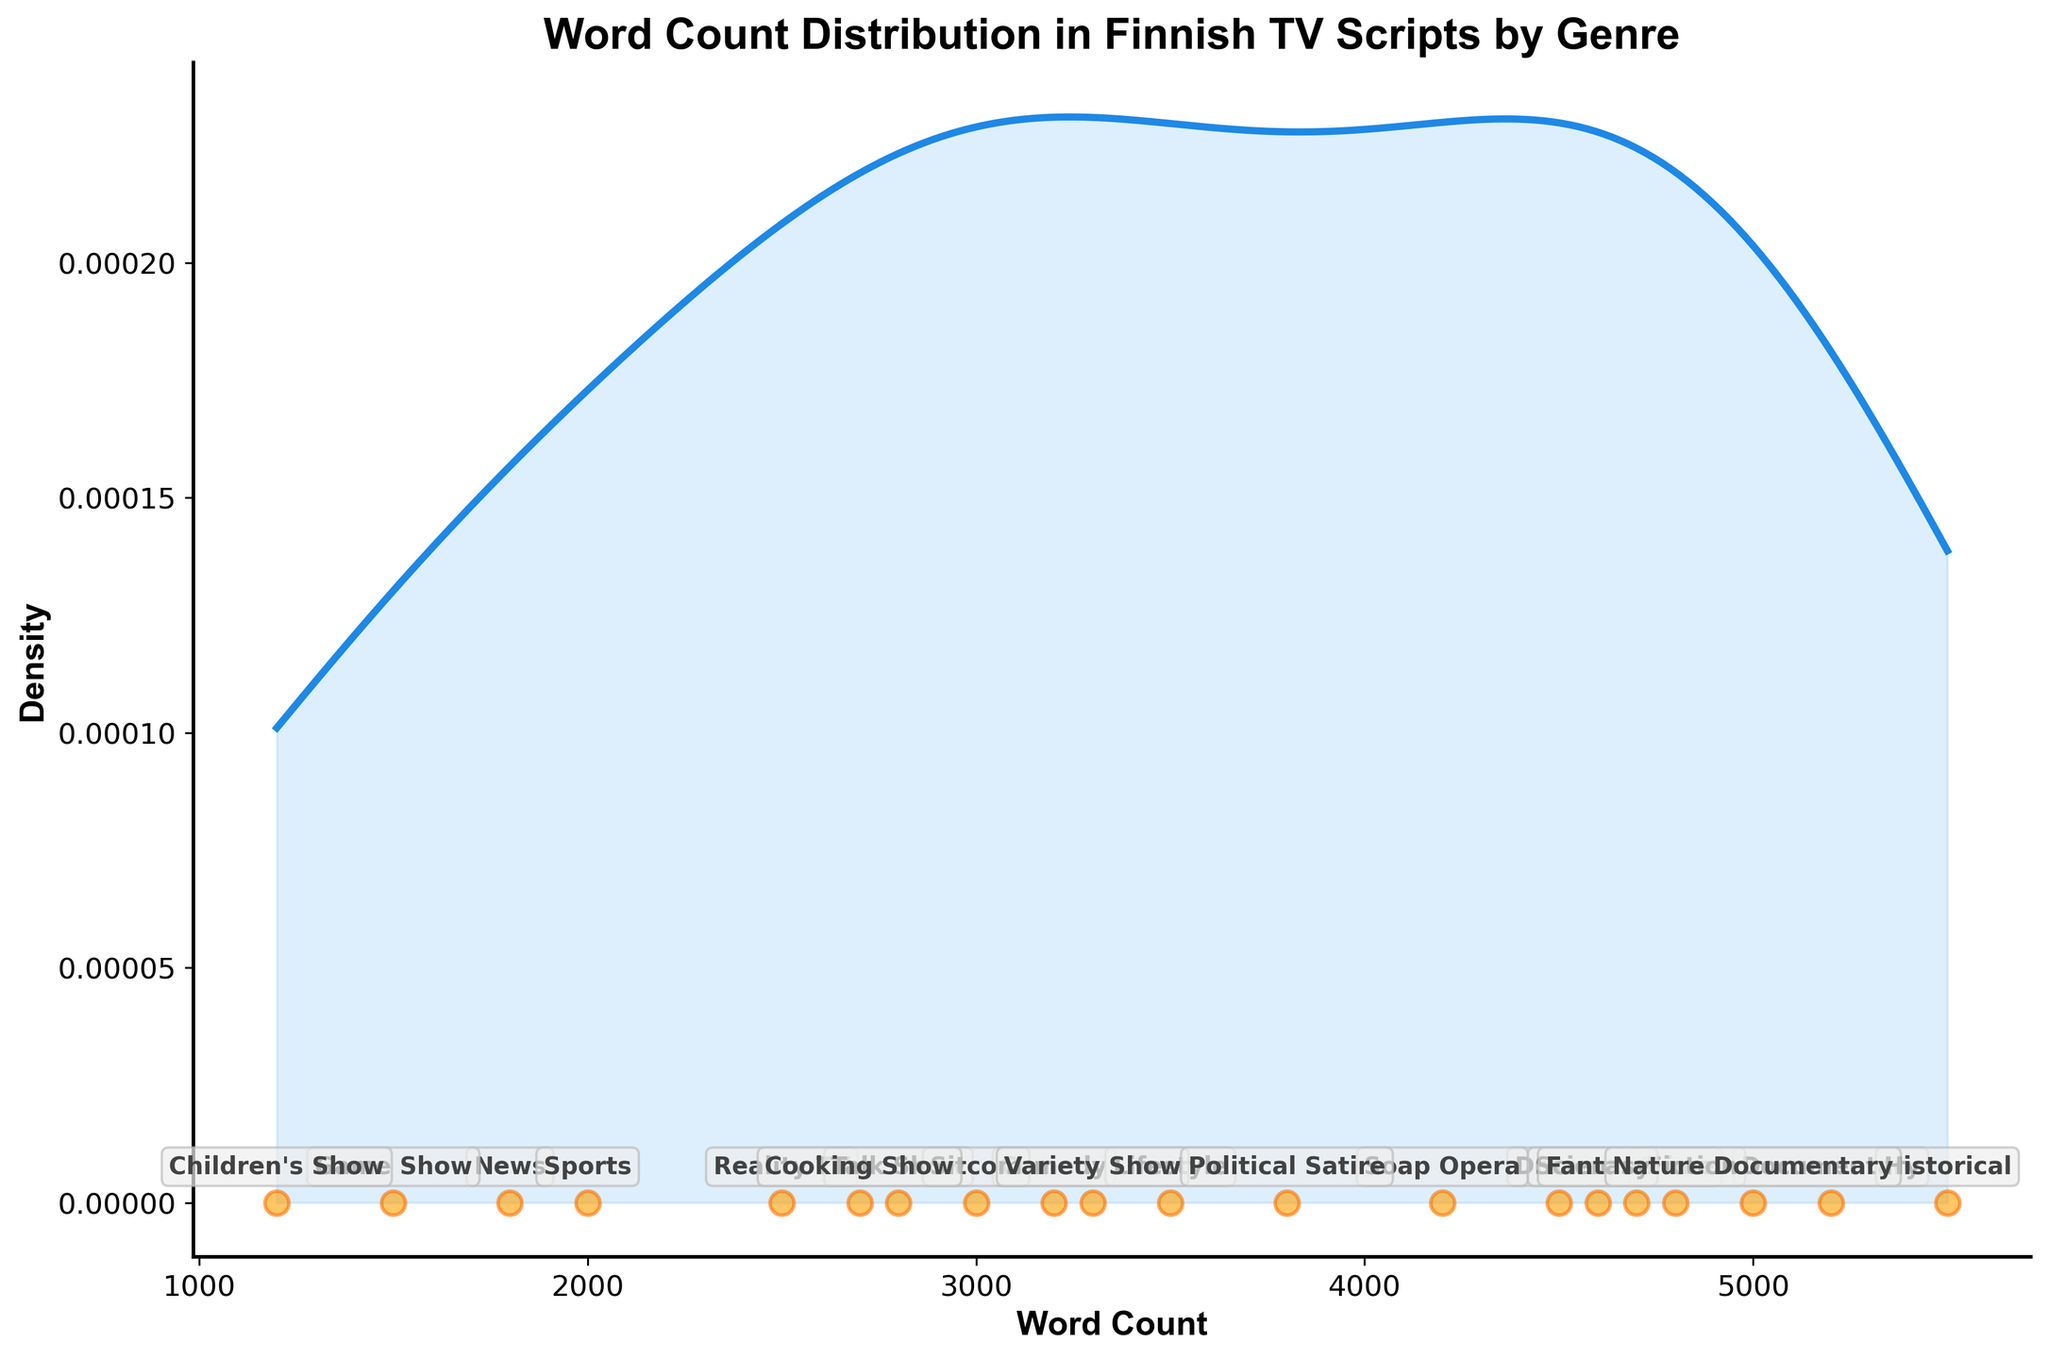What's the title of the figure? The title of the figure is written at the top and is clearly visible.
Answer: Word Count Distribution in Finnish TV Scripts by Genre How many genres are represented in the plot? By counting the number of annotations for genre names on the plot, we can determine the number of genres represented.
Answer: 20 What range of word counts is covered in the plot? By observing the x-axis, we can see the minimum and maximum values of word counts.
Answer: 1200 to 5500 Which genre has the highest word count? Locate the annotation with the highest word count on the plot.
Answer: Historical Which genre has the lowest word count? Locate the annotation with the lowest word count on the plot.
Answer: Children's Show Is the word count for 'Comedy' greater than 'Sitcom'? Compare the word count annotations of 'Comedy' and 'Sitcom' on the plot to determine which is higher.
Answer: Yes Which genre falls in the middle of the word count range? Identify the genre with the word count closest to the median of the range (around 3350).
Answer: Lifestyle What is the overall shape of the plot and what can it tell us about word count distribution? Observe the density curve and describe its overall shape (e.g., unimodal, bimodal) and what this indicates about the distribution of word counts.
Answer: Unimodal, indicating a single peak where most scripts have word counts around 4000 Are there more genres with word counts above or below the peak of the density curve? Identify the peak of the density curve and count the genres with word counts above and below this value.
Answer: Below 